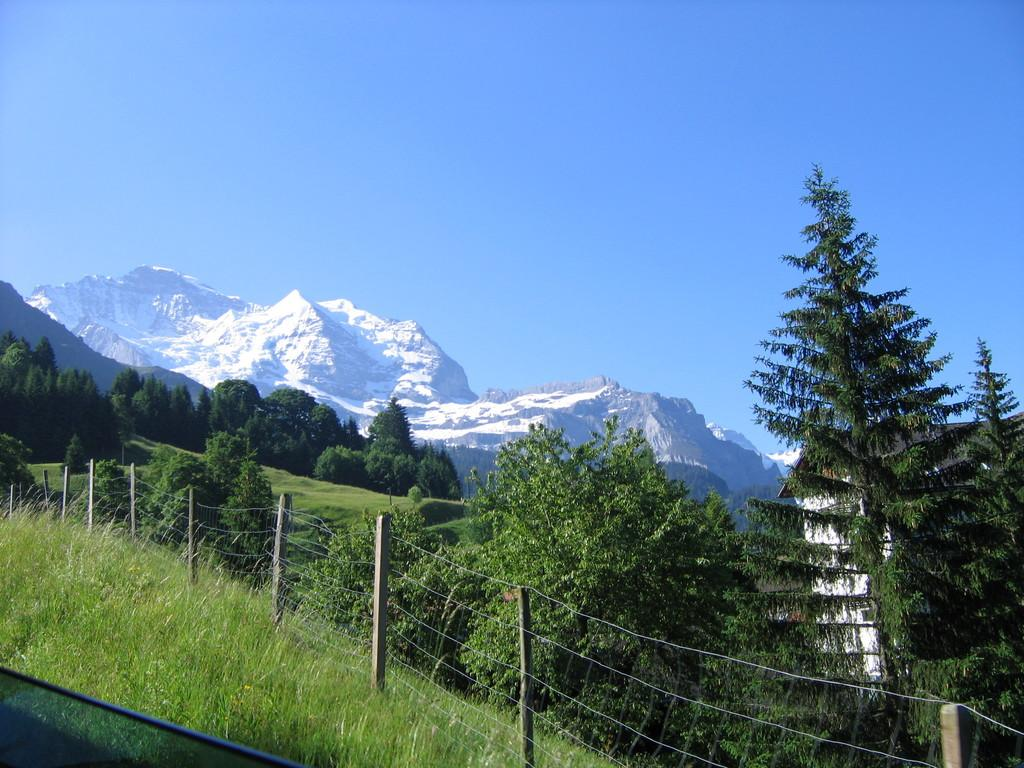What type of natural landforms can be seen in the image? There are mountains and hills in the image. What type of vegetation is present in the image? There are trees in the image. What type of ground cover is present in the image? There is grass in the image. What type of man-made structure can be seen in the image? There is a fence in the image. What part of the natural environment is visible in the image? The sky is visible in the image. Can you hear the legs crying in the image? There are no legs or crying sounds present in the image. What type of songs are being sung by the trees in the image? There are no songs or singing trees present in the image. 